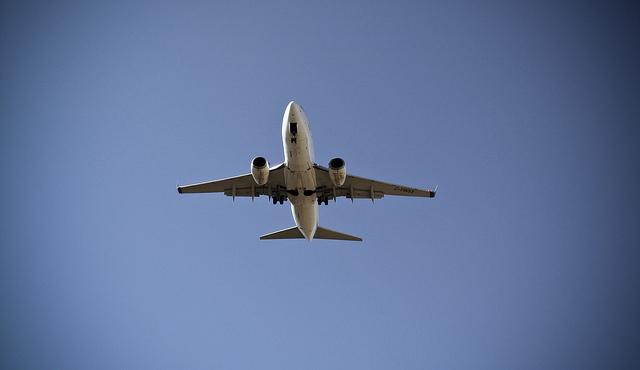Is this a clear day?
Answer briefly. Yes. How many propellers are on the plane?
Short answer required. 0. Are there clouds visible?
Short answer required. No. Is it cloudy?
Concise answer only. No. What is it doing?
Be succinct. Flying. 